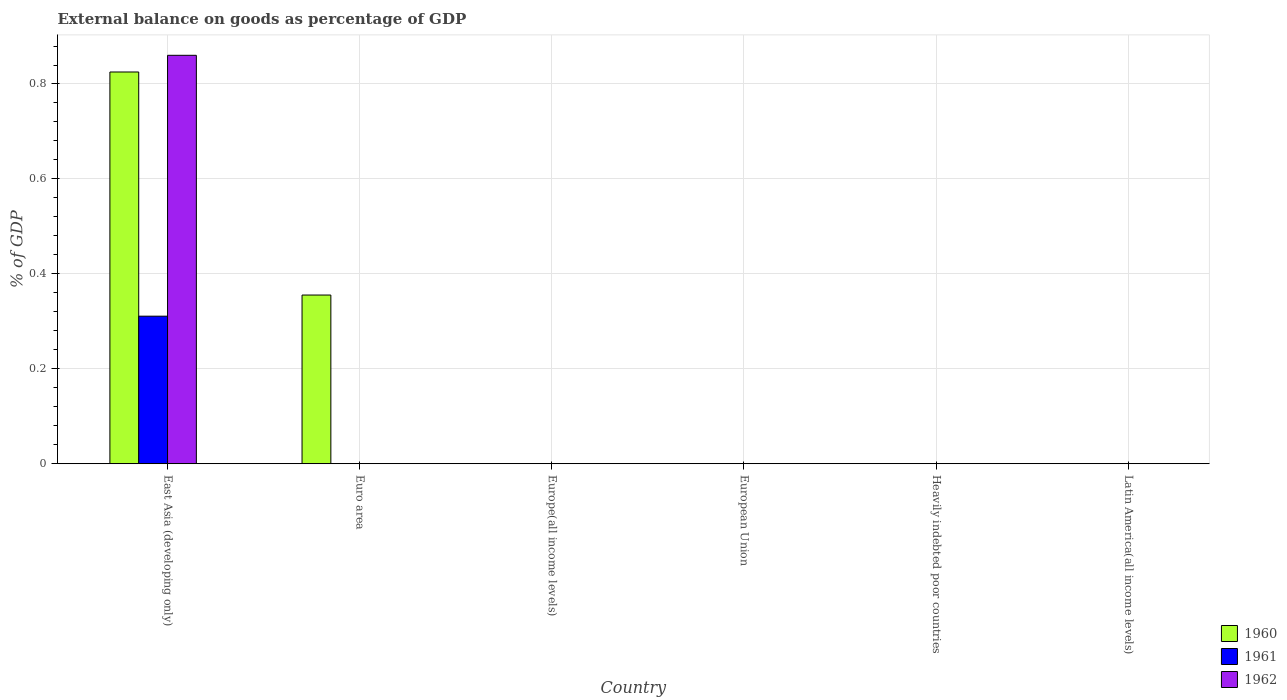How many different coloured bars are there?
Your response must be concise. 3. Are the number of bars per tick equal to the number of legend labels?
Provide a succinct answer. No. How many bars are there on the 6th tick from the left?
Keep it short and to the point. 0. How many bars are there on the 5th tick from the right?
Keep it short and to the point. 1. What is the label of the 5th group of bars from the left?
Offer a very short reply. Heavily indebted poor countries. What is the external balance on goods as percentage of GDP in 1960 in European Union?
Give a very brief answer. 0. Across all countries, what is the maximum external balance on goods as percentage of GDP in 1960?
Offer a very short reply. 0.83. Across all countries, what is the minimum external balance on goods as percentage of GDP in 1962?
Make the answer very short. 0. In which country was the external balance on goods as percentage of GDP in 1962 maximum?
Ensure brevity in your answer.  East Asia (developing only). What is the total external balance on goods as percentage of GDP in 1961 in the graph?
Your answer should be very brief. 0.31. What is the difference between the external balance on goods as percentage of GDP in 1960 in East Asia (developing only) and that in Euro area?
Your answer should be compact. 0.47. What is the average external balance on goods as percentage of GDP in 1960 per country?
Your response must be concise. 0.2. In how many countries, is the external balance on goods as percentage of GDP in 1960 greater than 0.28 %?
Ensure brevity in your answer.  2. What is the difference between the highest and the lowest external balance on goods as percentage of GDP in 1961?
Your response must be concise. 0.31. In how many countries, is the external balance on goods as percentage of GDP in 1960 greater than the average external balance on goods as percentage of GDP in 1960 taken over all countries?
Offer a very short reply. 2. Is it the case that in every country, the sum of the external balance on goods as percentage of GDP in 1960 and external balance on goods as percentage of GDP in 1962 is greater than the external balance on goods as percentage of GDP in 1961?
Provide a short and direct response. No. Are all the bars in the graph horizontal?
Provide a succinct answer. No. How many countries are there in the graph?
Provide a short and direct response. 6. Are the values on the major ticks of Y-axis written in scientific E-notation?
Your response must be concise. No. Where does the legend appear in the graph?
Make the answer very short. Bottom right. How many legend labels are there?
Provide a succinct answer. 3. How are the legend labels stacked?
Offer a very short reply. Vertical. What is the title of the graph?
Make the answer very short. External balance on goods as percentage of GDP. Does "1972" appear as one of the legend labels in the graph?
Offer a terse response. No. What is the label or title of the X-axis?
Provide a succinct answer. Country. What is the label or title of the Y-axis?
Make the answer very short. % of GDP. What is the % of GDP in 1960 in East Asia (developing only)?
Keep it short and to the point. 0.83. What is the % of GDP in 1961 in East Asia (developing only)?
Your response must be concise. 0.31. What is the % of GDP in 1962 in East Asia (developing only)?
Offer a very short reply. 0.86. What is the % of GDP of 1960 in Euro area?
Give a very brief answer. 0.36. What is the % of GDP in 1961 in Euro area?
Your answer should be very brief. 0. What is the % of GDP in 1960 in Europe(all income levels)?
Make the answer very short. 0. What is the % of GDP in 1961 in Europe(all income levels)?
Your response must be concise. 0. What is the % of GDP in 1960 in European Union?
Your response must be concise. 0. What is the % of GDP in 1961 in European Union?
Provide a short and direct response. 0. What is the % of GDP of 1960 in Latin America(all income levels)?
Your response must be concise. 0. Across all countries, what is the maximum % of GDP of 1960?
Keep it short and to the point. 0.83. Across all countries, what is the maximum % of GDP of 1961?
Offer a very short reply. 0.31. Across all countries, what is the maximum % of GDP of 1962?
Give a very brief answer. 0.86. Across all countries, what is the minimum % of GDP of 1960?
Ensure brevity in your answer.  0. Across all countries, what is the minimum % of GDP of 1961?
Offer a terse response. 0. Across all countries, what is the minimum % of GDP of 1962?
Keep it short and to the point. 0. What is the total % of GDP in 1960 in the graph?
Provide a succinct answer. 1.18. What is the total % of GDP of 1961 in the graph?
Ensure brevity in your answer.  0.31. What is the total % of GDP in 1962 in the graph?
Provide a succinct answer. 0.86. What is the difference between the % of GDP of 1960 in East Asia (developing only) and that in Euro area?
Your answer should be compact. 0.47. What is the average % of GDP in 1960 per country?
Provide a short and direct response. 0.2. What is the average % of GDP of 1961 per country?
Your answer should be compact. 0.05. What is the average % of GDP in 1962 per country?
Your answer should be very brief. 0.14. What is the difference between the % of GDP of 1960 and % of GDP of 1961 in East Asia (developing only)?
Make the answer very short. 0.51. What is the difference between the % of GDP in 1960 and % of GDP in 1962 in East Asia (developing only)?
Your answer should be very brief. -0.04. What is the difference between the % of GDP of 1961 and % of GDP of 1962 in East Asia (developing only)?
Offer a very short reply. -0.55. What is the ratio of the % of GDP in 1960 in East Asia (developing only) to that in Euro area?
Ensure brevity in your answer.  2.32. What is the difference between the highest and the lowest % of GDP in 1960?
Offer a terse response. 0.83. What is the difference between the highest and the lowest % of GDP in 1961?
Make the answer very short. 0.31. What is the difference between the highest and the lowest % of GDP in 1962?
Provide a succinct answer. 0.86. 